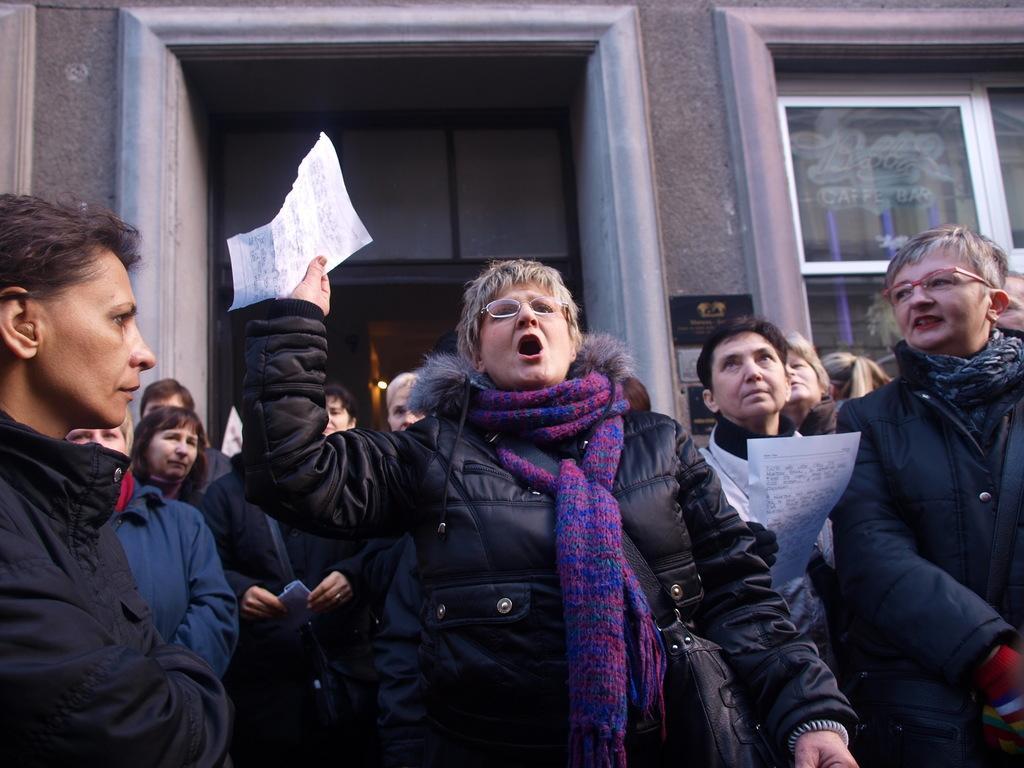Can you describe this image briefly? In this image there are two people holding papers in their hands, in the background there are people standing and there is a building for that building there are doors and windows. 